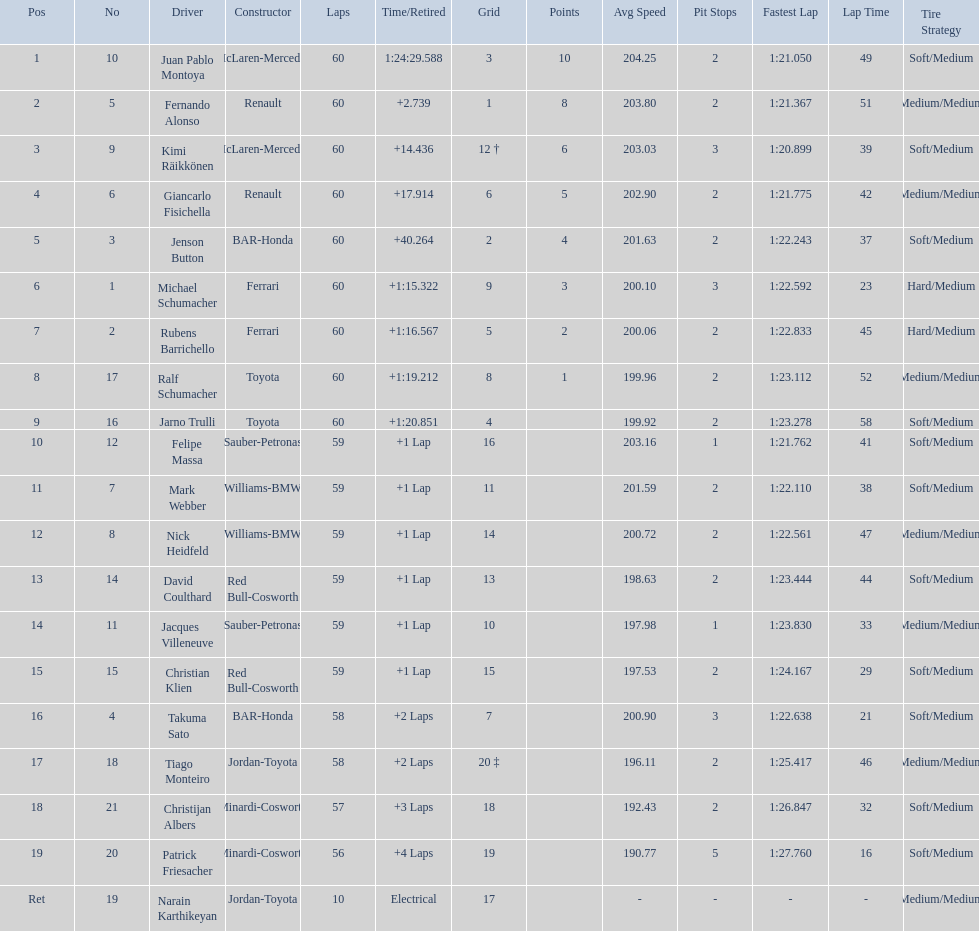Which driver has his grid at 2? Jenson Button. 